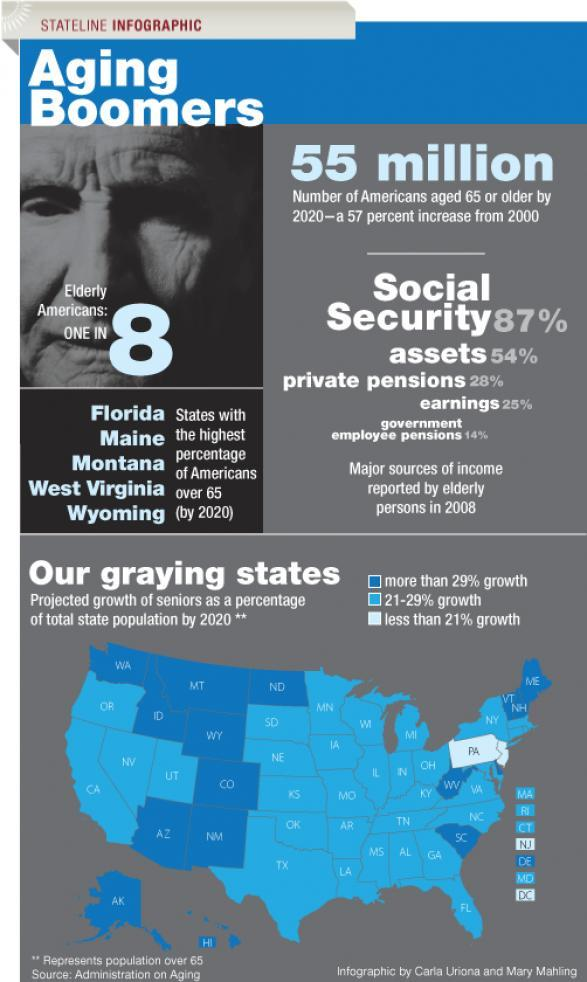What is the difference between private pensions and earnings?
Answer the question with a short phrase. 3% What is the difference between social Security and assets? 33% What is the difference between earnings and government employee pensions? 11% What is the difference between assets and private pensions? 26% 